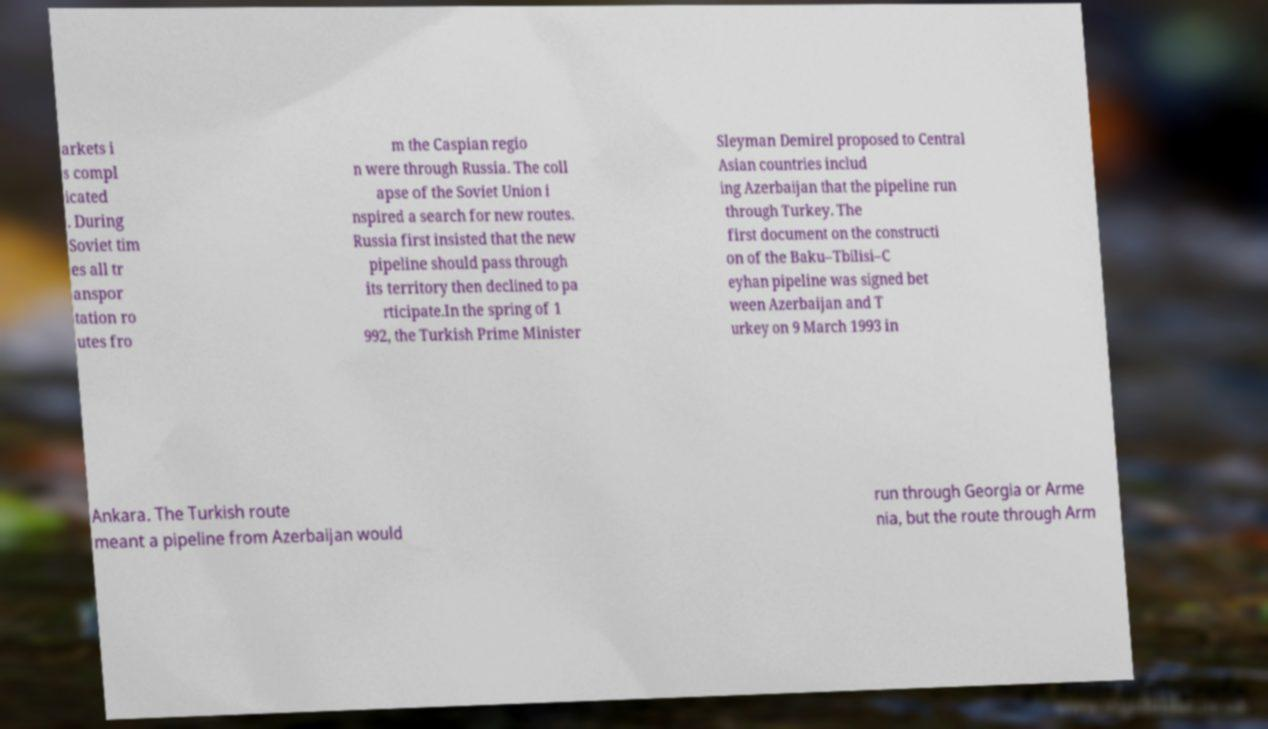Could you extract and type out the text from this image? arkets i s compl icated . During Soviet tim es all tr anspor tation ro utes fro m the Caspian regio n were through Russia. The coll apse of the Soviet Union i nspired a search for new routes. Russia first insisted that the new pipeline should pass through its territory then declined to pa rticipate.In the spring of 1 992, the Turkish Prime Minister Sleyman Demirel proposed to Central Asian countries includ ing Azerbaijan that the pipeline run through Turkey. The first document on the constructi on of the Baku–Tbilisi–C eyhan pipeline was signed bet ween Azerbaijan and T urkey on 9 March 1993 in Ankara. The Turkish route meant a pipeline from Azerbaijan would run through Georgia or Arme nia, but the route through Arm 